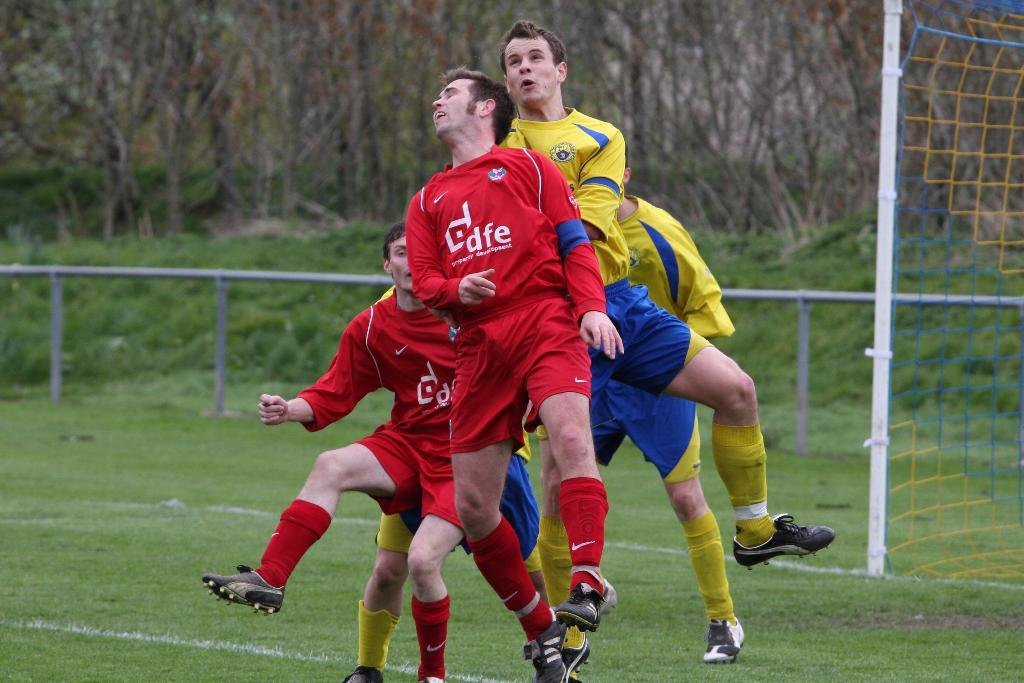<image>
Render a clear and concise summary of the photo. Teammates in red DFE uniforms compete against the opposing team in their yellow uniforms. 